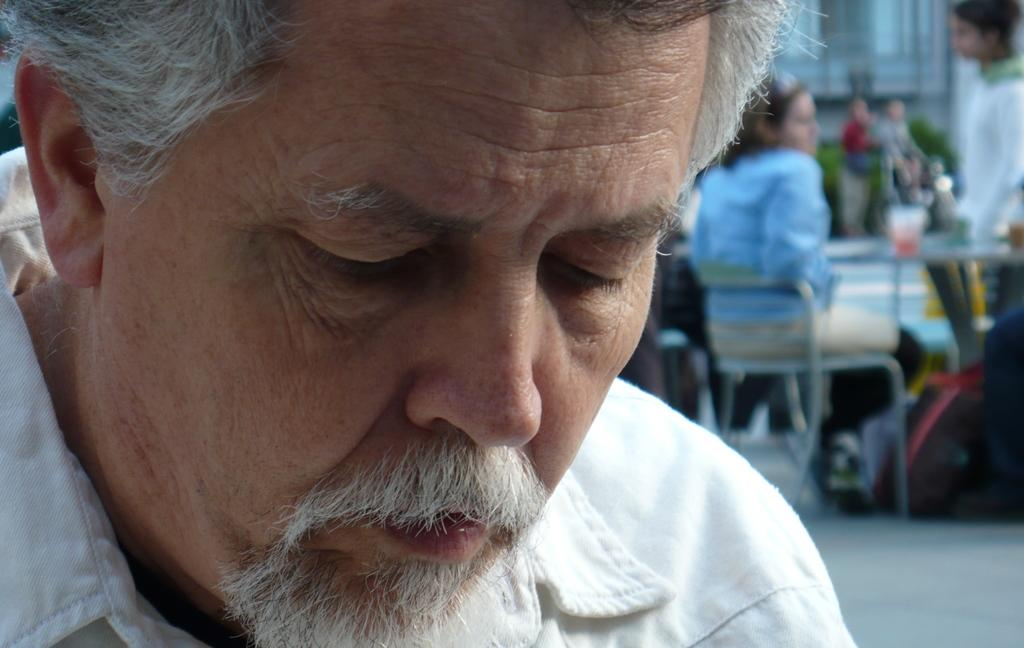What is the person in the image wearing? There is a person wearing a white dress in the image. What can be observed about the person's facial hair? The person has a white mustache. Are there any other people visible in the image? Yes, there are other persons in the right corner of the image. What type of goose is present in the image? There is no goose present in the image. 